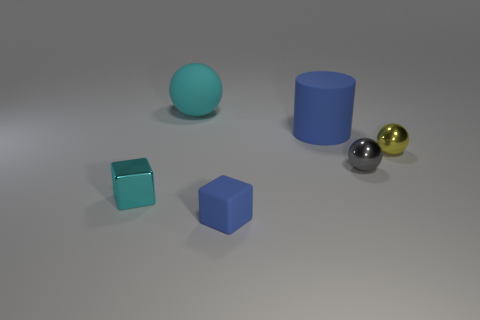Subtract all large balls. How many balls are left? 2 Subtract all blocks. How many objects are left? 4 Subtract all cyan spheres. How many spheres are left? 2 Add 3 tiny shiny cubes. How many tiny shiny cubes are left? 4 Add 1 big yellow things. How many big yellow things exist? 1 Add 4 big red metallic cubes. How many objects exist? 10 Subtract 1 cyan balls. How many objects are left? 5 Subtract 2 balls. How many balls are left? 1 Subtract all gray cubes. Subtract all purple cylinders. How many cubes are left? 2 Subtract all red cubes. How many gray balls are left? 1 